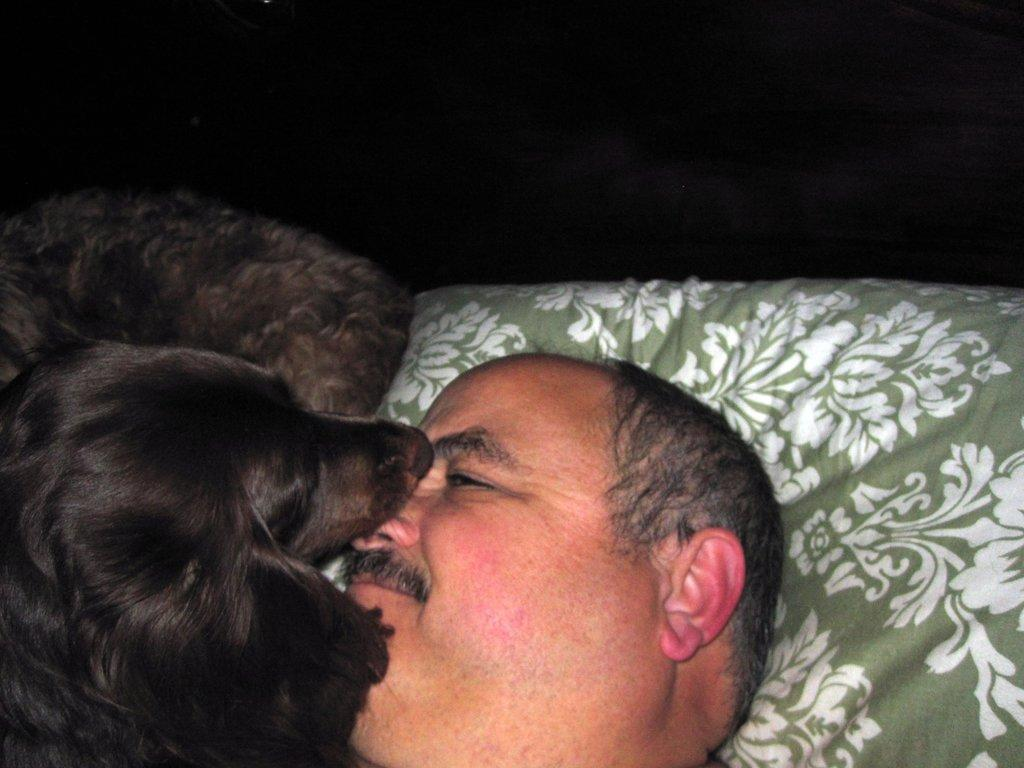What is the main subject of the image? The main subject of the image is a man. What is the man doing in the image? The man is lying on a bed. Is there any other living creature present in the image? Yes, there is a dog in the image. Where is the dog located in relation to the man? The dog is beside the man. What type of yard work is the man teaching the hen in the image? There is no hen present in the image, and the man is not teaching any yard work. 